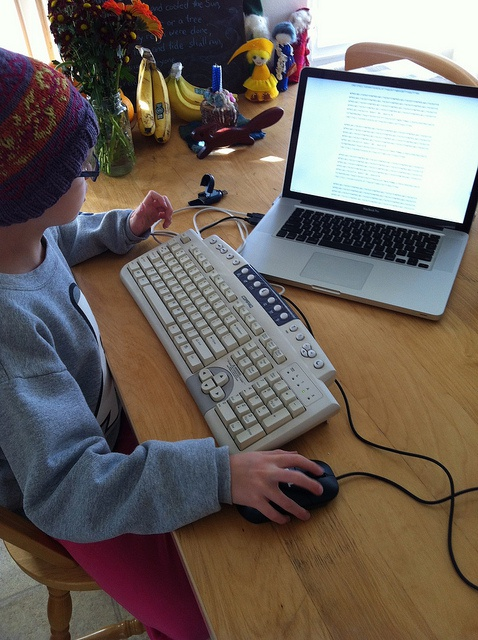Describe the objects in this image and their specific colors. I can see dining table in ivory, brown, gray, olive, and maroon tones, people in ivory, black, gray, maroon, and darkblue tones, laptop in ivory, black, darkgray, and gray tones, keyboard in ivory, darkgray, gray, black, and navy tones, and keyboard in ivory, black, darkgray, and gray tones in this image. 